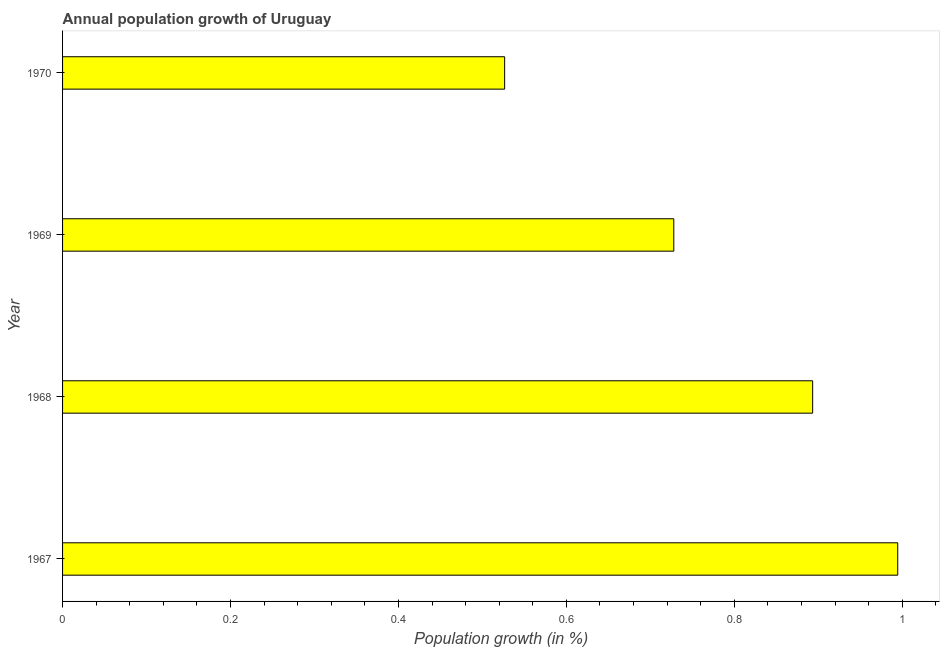Does the graph contain any zero values?
Provide a short and direct response. No. What is the title of the graph?
Give a very brief answer. Annual population growth of Uruguay. What is the label or title of the X-axis?
Your answer should be very brief. Population growth (in %). What is the label or title of the Y-axis?
Your answer should be compact. Year. What is the population growth in 1967?
Provide a short and direct response. 0.99. Across all years, what is the maximum population growth?
Give a very brief answer. 0.99. Across all years, what is the minimum population growth?
Provide a succinct answer. 0.53. In which year was the population growth maximum?
Keep it short and to the point. 1967. In which year was the population growth minimum?
Ensure brevity in your answer.  1970. What is the sum of the population growth?
Ensure brevity in your answer.  3.14. What is the difference between the population growth in 1969 and 1970?
Ensure brevity in your answer.  0.2. What is the average population growth per year?
Keep it short and to the point. 0.79. What is the median population growth?
Your answer should be compact. 0.81. Do a majority of the years between 1967 and 1969 (inclusive) have population growth greater than 0.76 %?
Keep it short and to the point. Yes. What is the ratio of the population growth in 1968 to that in 1969?
Make the answer very short. 1.23. What is the difference between the highest and the second highest population growth?
Your answer should be very brief. 0.1. Is the sum of the population growth in 1969 and 1970 greater than the maximum population growth across all years?
Provide a succinct answer. Yes. What is the difference between the highest and the lowest population growth?
Provide a succinct answer. 0.47. In how many years, is the population growth greater than the average population growth taken over all years?
Your answer should be very brief. 2. How many bars are there?
Offer a very short reply. 4. Are all the bars in the graph horizontal?
Ensure brevity in your answer.  Yes. Are the values on the major ticks of X-axis written in scientific E-notation?
Your response must be concise. No. What is the Population growth (in %) in 1967?
Offer a very short reply. 0.99. What is the Population growth (in %) in 1968?
Your answer should be very brief. 0.89. What is the Population growth (in %) in 1969?
Offer a very short reply. 0.73. What is the Population growth (in %) of 1970?
Your answer should be compact. 0.53. What is the difference between the Population growth (in %) in 1967 and 1968?
Offer a terse response. 0.1. What is the difference between the Population growth (in %) in 1967 and 1969?
Give a very brief answer. 0.27. What is the difference between the Population growth (in %) in 1967 and 1970?
Ensure brevity in your answer.  0.47. What is the difference between the Population growth (in %) in 1968 and 1969?
Provide a short and direct response. 0.17. What is the difference between the Population growth (in %) in 1968 and 1970?
Your answer should be compact. 0.37. What is the difference between the Population growth (in %) in 1969 and 1970?
Offer a terse response. 0.2. What is the ratio of the Population growth (in %) in 1967 to that in 1968?
Offer a terse response. 1.11. What is the ratio of the Population growth (in %) in 1967 to that in 1969?
Your response must be concise. 1.37. What is the ratio of the Population growth (in %) in 1967 to that in 1970?
Your response must be concise. 1.89. What is the ratio of the Population growth (in %) in 1968 to that in 1969?
Make the answer very short. 1.23. What is the ratio of the Population growth (in %) in 1968 to that in 1970?
Your response must be concise. 1.7. What is the ratio of the Population growth (in %) in 1969 to that in 1970?
Make the answer very short. 1.38. 